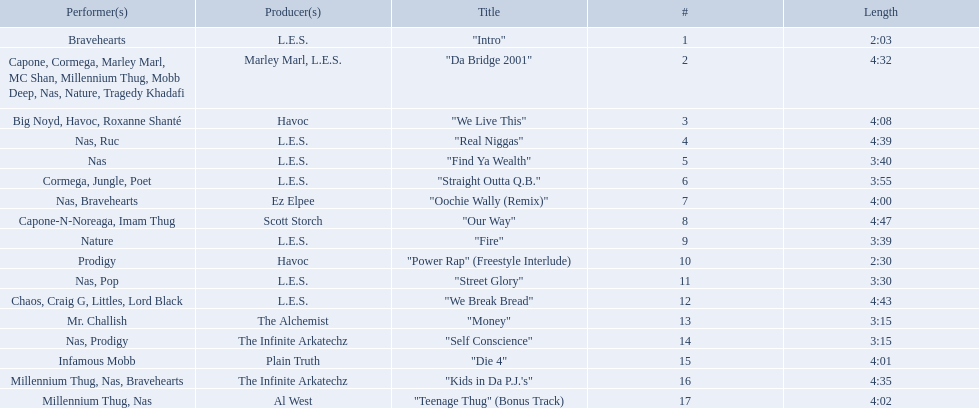What are the track lengths on the album? 2:03, 4:32, 4:08, 4:39, 3:40, 3:55, 4:00, 4:47, 3:39, 2:30, 3:30, 4:43, 3:15, 3:15, 4:01, 4:35, 4:02. What is the longest length? 4:47. 